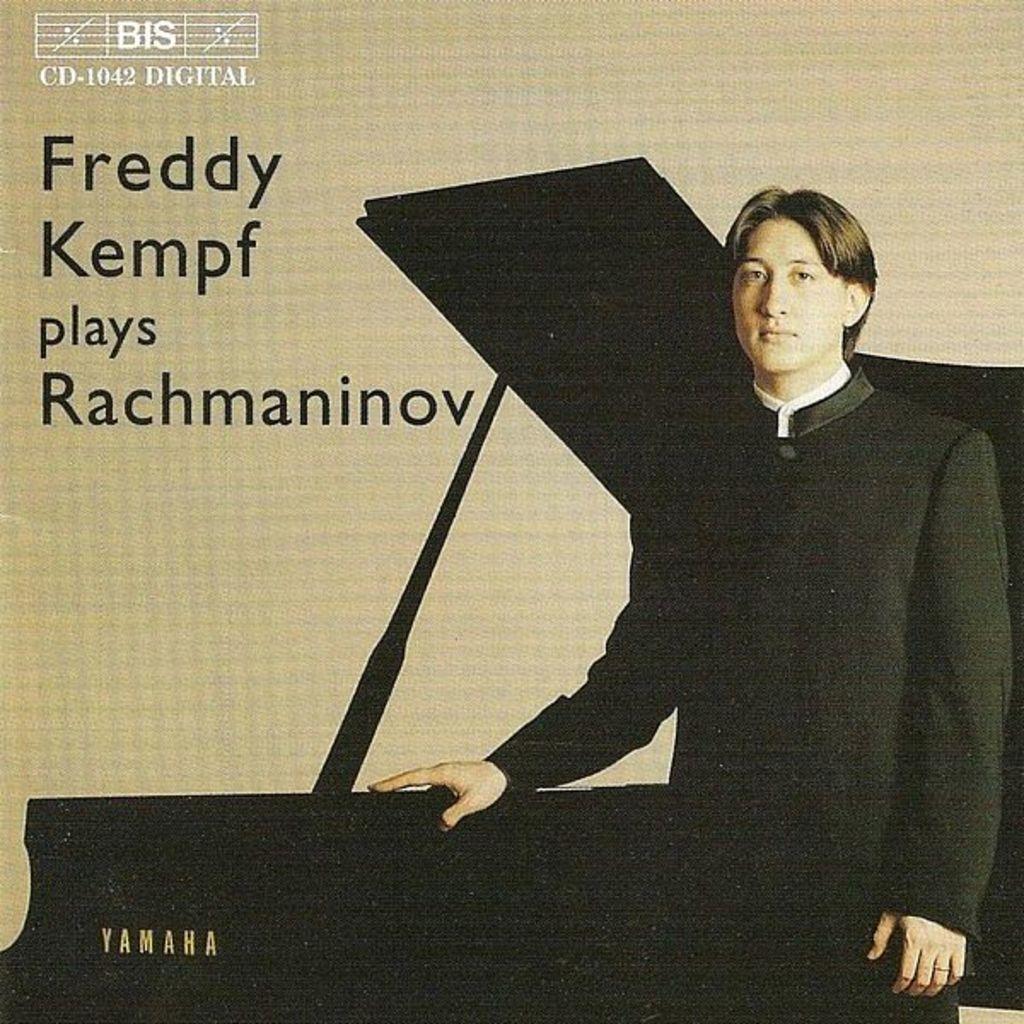In one or two sentences, can you explain what this image depicts? In this a black color guy is standing and holding a piano which is named as Yamaha. In the background there is written as "freddy kempf plays rachmaninov" , on top of it there is also a label written as BIS. 